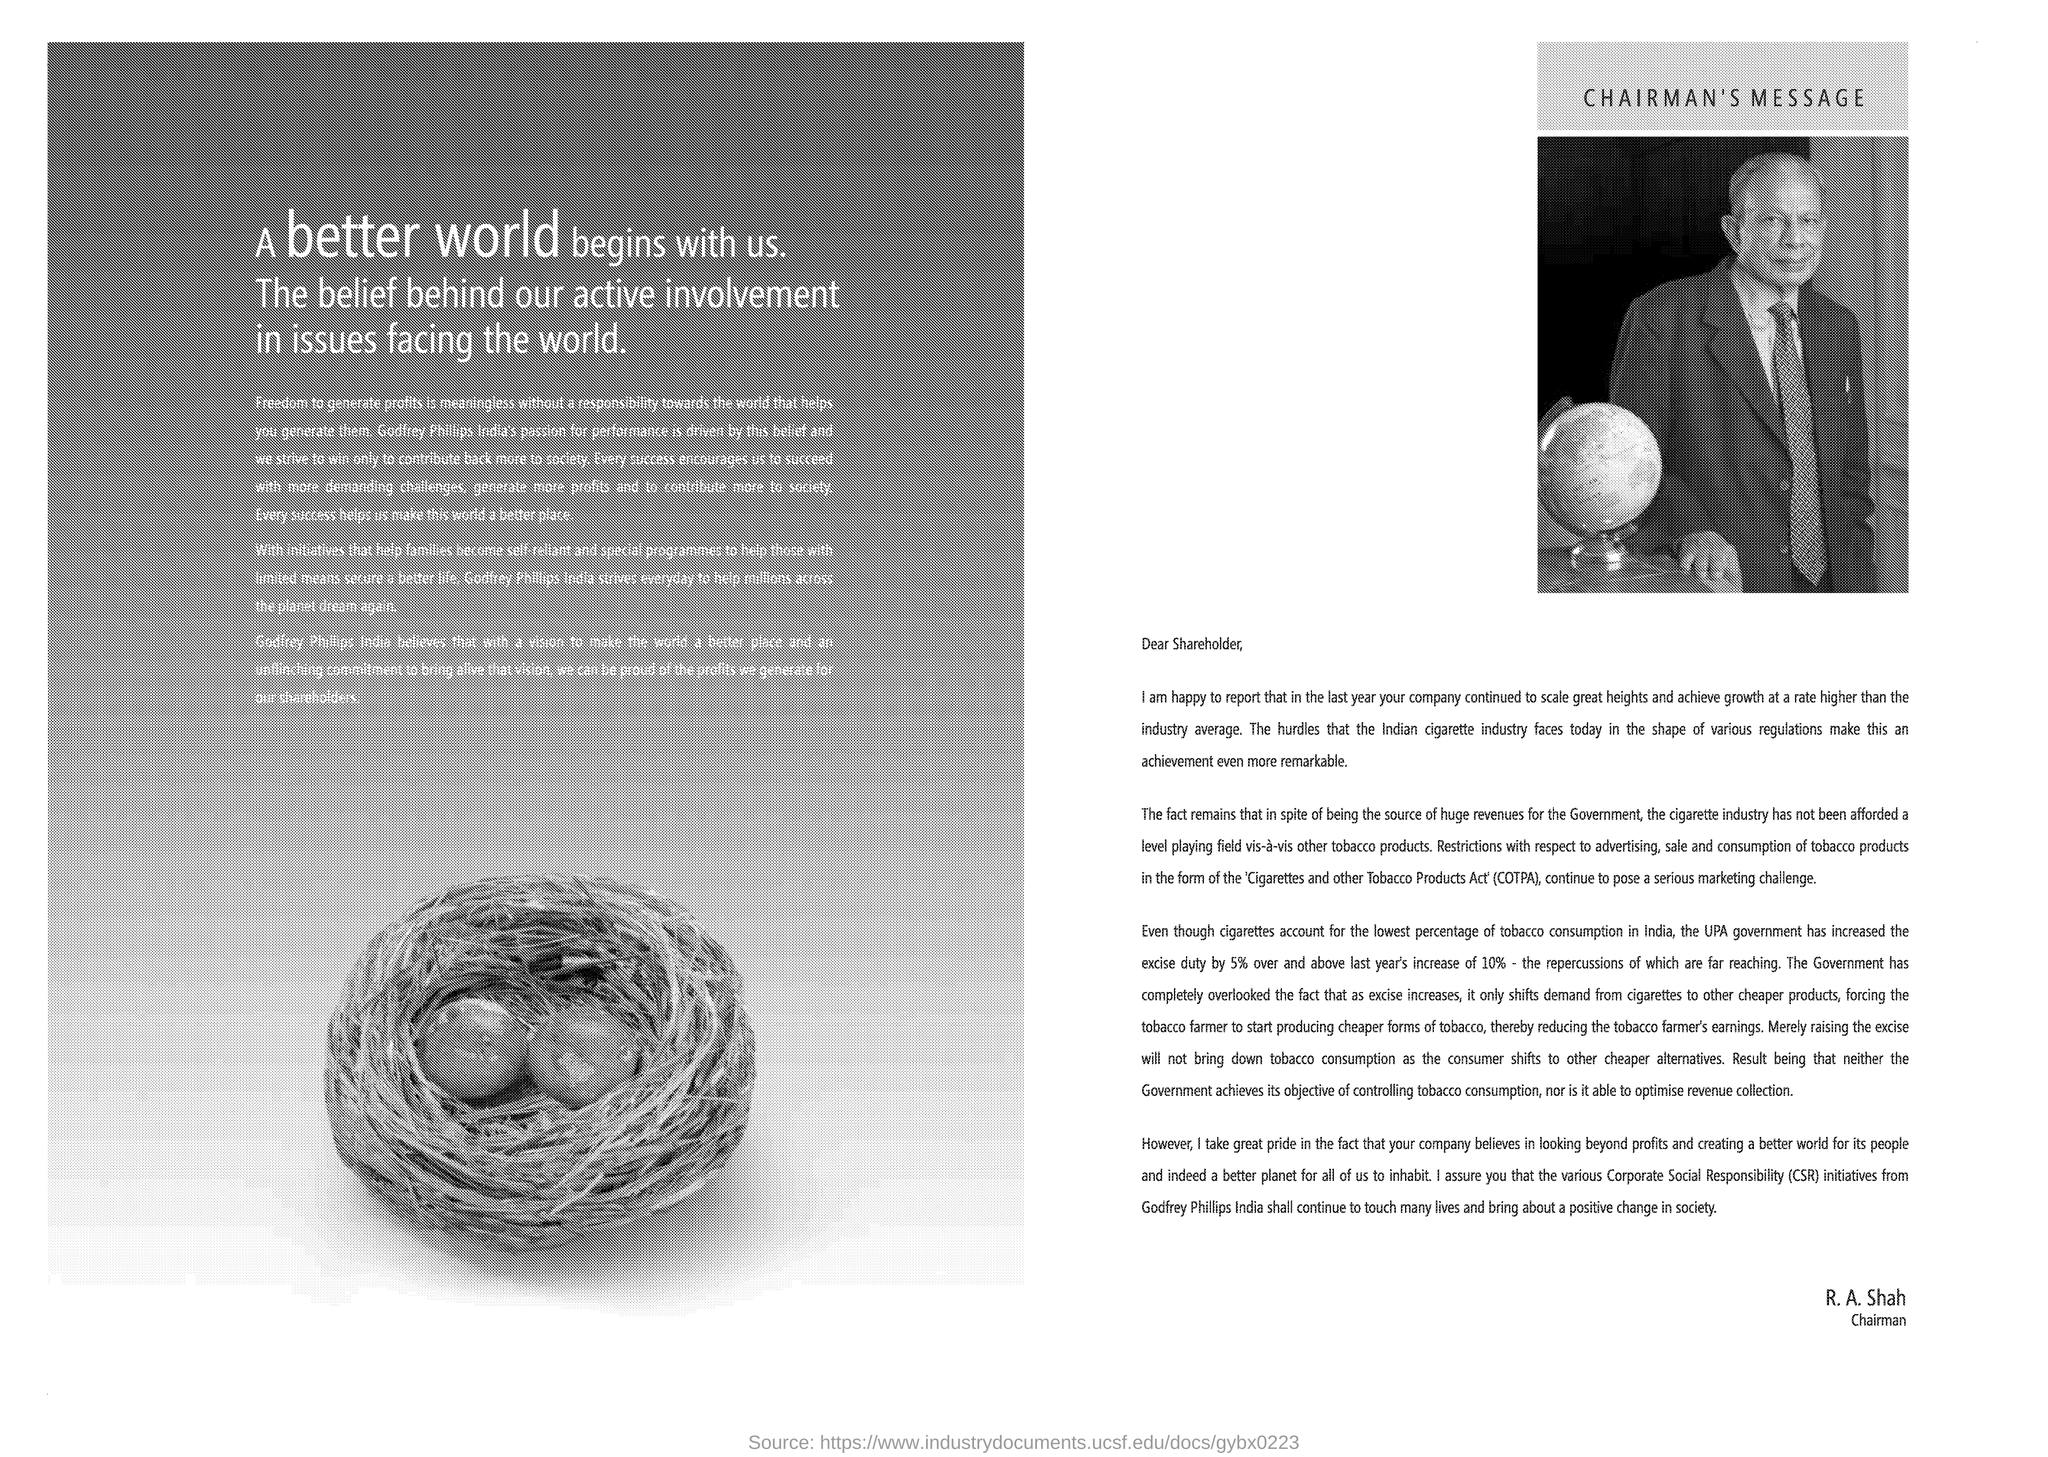Draw attention to some important aspects in this diagram. The excise duty increase from the previous year was 10%. Raising the excise duty on tobacco products will not effectively reduce consumption, as consumers will simply switch to cheaper alternatives. 